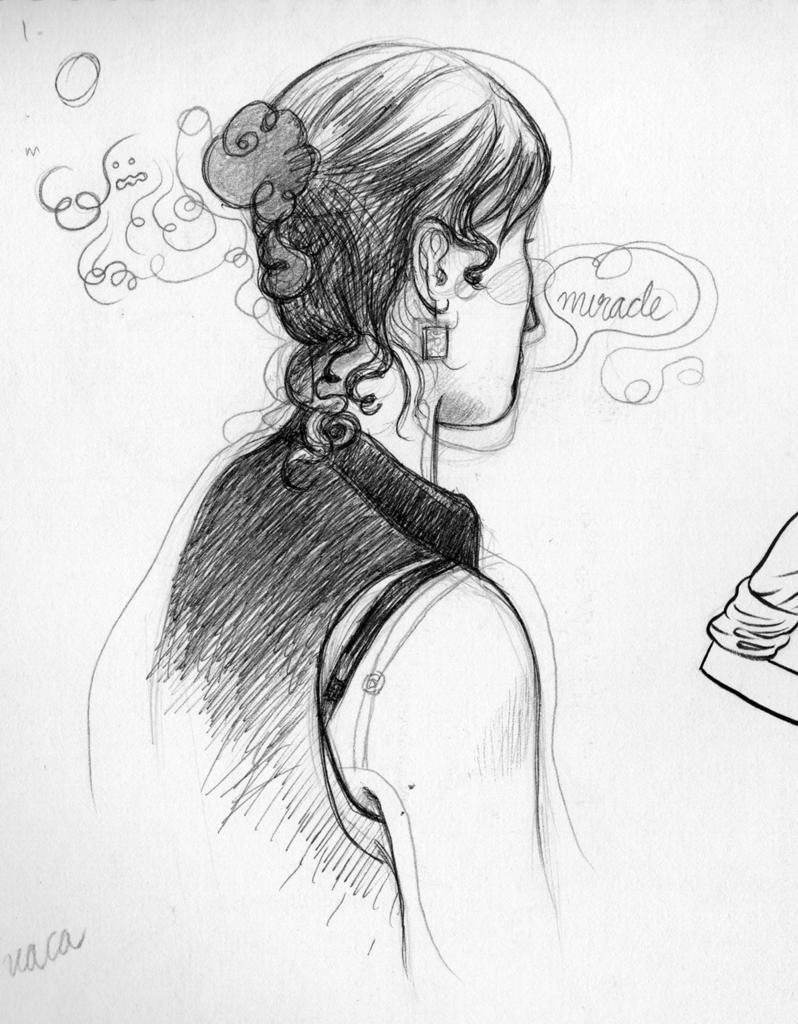How would you summarize this image in a sentence or two? In this image we can see the pencil sketch of a woman. 